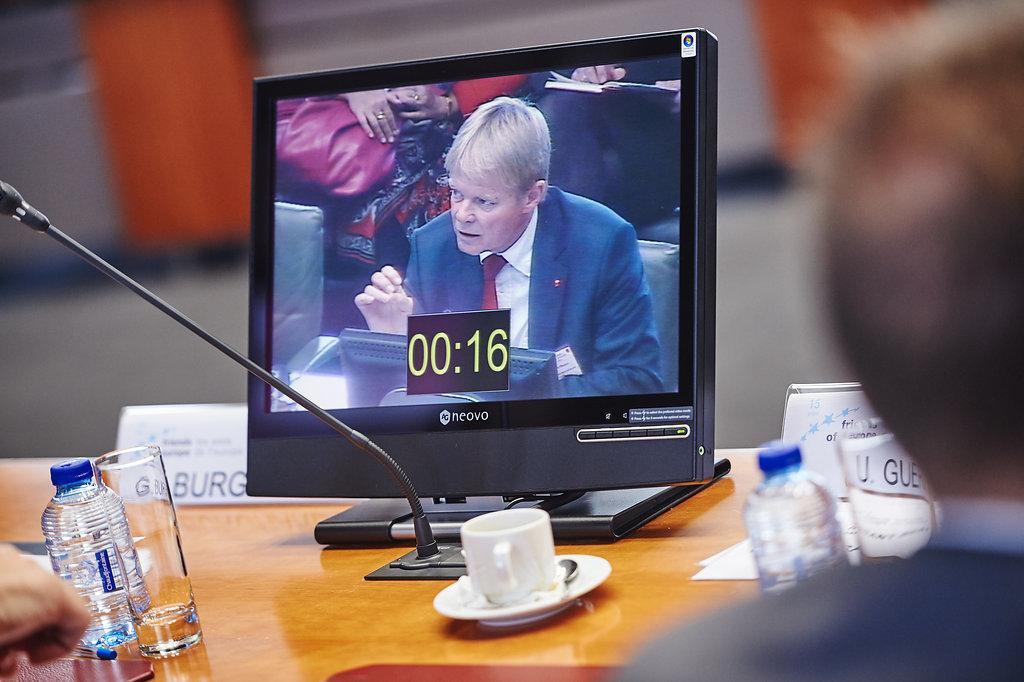Can you describe this image briefly? In this image we can see a person sitting beside a table containing a monitor screen with the picture of a person, a mic with a stand, a cup in a saucer, some glasses, bottles and a name board on it. On the left bottom we can see the hand of a person. 